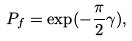<formula> <loc_0><loc_0><loc_500><loc_500>P _ { f } = \exp ( - \frac { \pi } { 2 } \gamma ) ,</formula> 